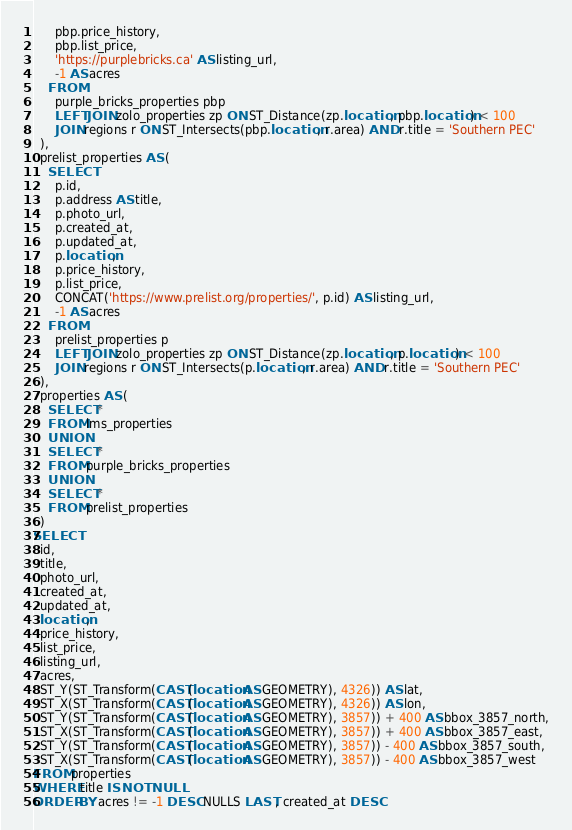Convert code to text. <code><loc_0><loc_0><loc_500><loc_500><_SQL_>      pbp.price_history,
      pbp.list_price,
      'https://purplebricks.ca' AS listing_url,
      -1 AS acres
    FROM
      purple_bricks_properties pbp
      LEFT JOIN zolo_properties zp ON ST_Distance(zp.location, pbp.location) < 100
      JOIN regions r ON ST_Intersects(pbp.location, r.area) AND r.title = 'Southern PEC'
  ),
  prelist_properties AS (
    SELECT
      p.id,
      p.address AS title,
      p.photo_url,
      p.created_at,
      p.updated_at,
      p.location,
      p.price_history,
      p.list_price,
      CONCAT('https://www.prelist.org/properties/', p.id) AS listing_url,
      -1 AS acres
    FROM
      prelist_properties p
      LEFT JOIN zolo_properties zp ON ST_Distance(zp.location, p.location) < 100
      JOIN regions r ON ST_Intersects(p.location, r.area) AND r.title = 'Southern PEC'
  ),
  properties AS (
    SELECT *
    FROM lms_properties
    UNION
    SELECT *
    FROM purple_bricks_properties
    UNION
    SELECT *
    FROM prelist_properties
  )
SELECT
  id,
  title,
  photo_url,
  created_at,
  updated_at,
  location,
  price_history,
  list_price,
  listing_url,
  acres,
  ST_Y(ST_Transform(CAST(location AS GEOMETRY), 4326)) AS lat,
  ST_X(ST_Transform(CAST(location AS GEOMETRY), 4326)) AS lon,
  ST_Y(ST_Transform(CAST(location AS GEOMETRY), 3857)) + 400 AS bbox_3857_north,
  ST_X(ST_Transform(CAST(location AS GEOMETRY), 3857)) + 400 AS bbox_3857_east,
  ST_Y(ST_Transform(CAST(location AS GEOMETRY), 3857)) - 400 AS bbox_3857_south,
  ST_X(ST_Transform(CAST(location AS GEOMETRY), 3857)) - 400 AS bbox_3857_west
FROM properties
WHERE title IS NOT NULL
ORDER BY acres != -1 DESC NULLS LAST, created_at DESC</code> 